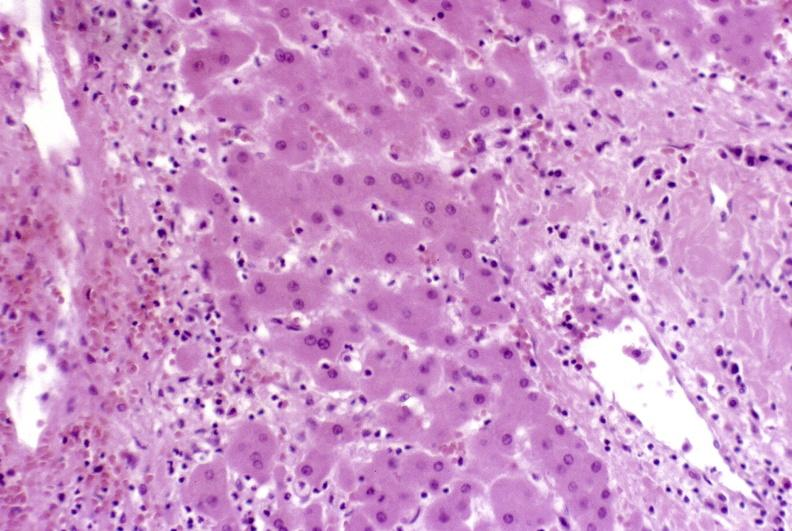what is present?
Answer the question using a single word or phrase. Hepatobiliary 